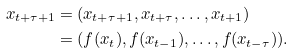<formula> <loc_0><loc_0><loc_500><loc_500>x _ { t + \tau + 1 } & = ( x _ { t + \tau + 1 } , x _ { t + \tau } , \dots , x _ { t + 1 } ) \\ & = ( f ( x _ { t } ) , f ( x _ { t - 1 } ) , \dots , f ( x _ { t - \tau } ) ) .</formula> 